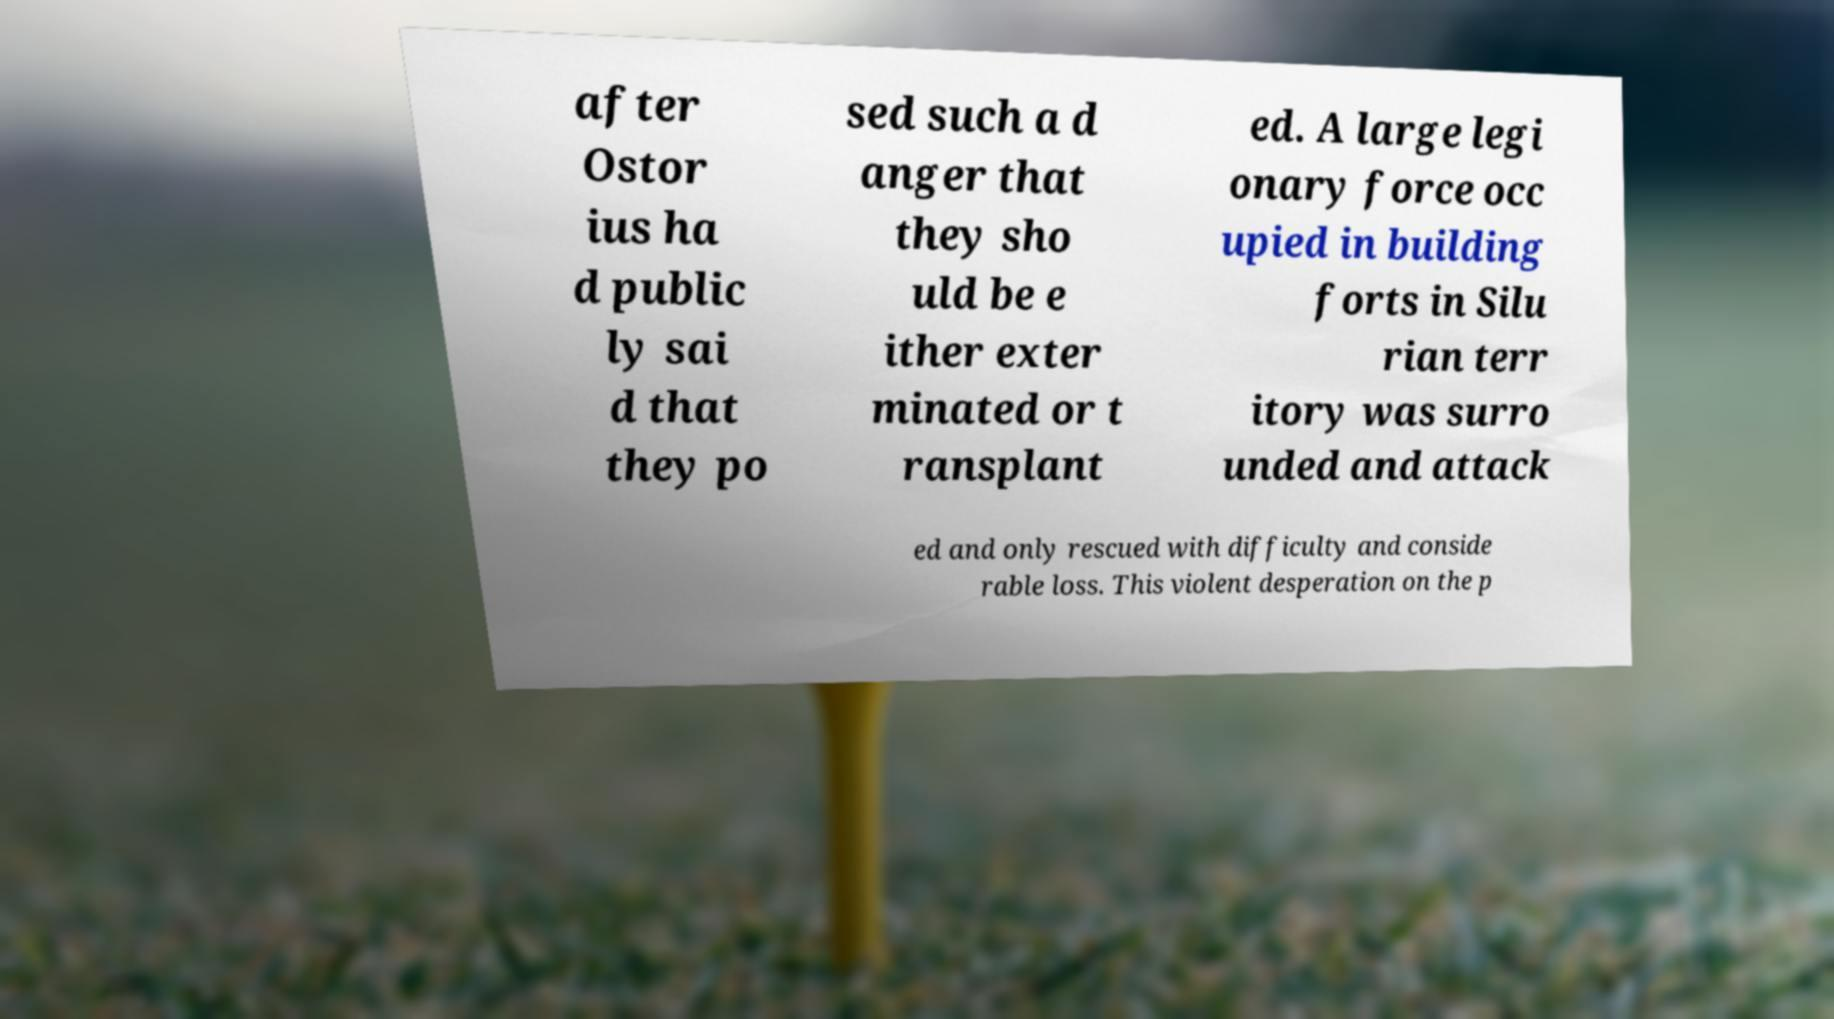For documentation purposes, I need the text within this image transcribed. Could you provide that? after Ostor ius ha d public ly sai d that they po sed such a d anger that they sho uld be e ither exter minated or t ransplant ed. A large legi onary force occ upied in building forts in Silu rian terr itory was surro unded and attack ed and only rescued with difficulty and conside rable loss. This violent desperation on the p 